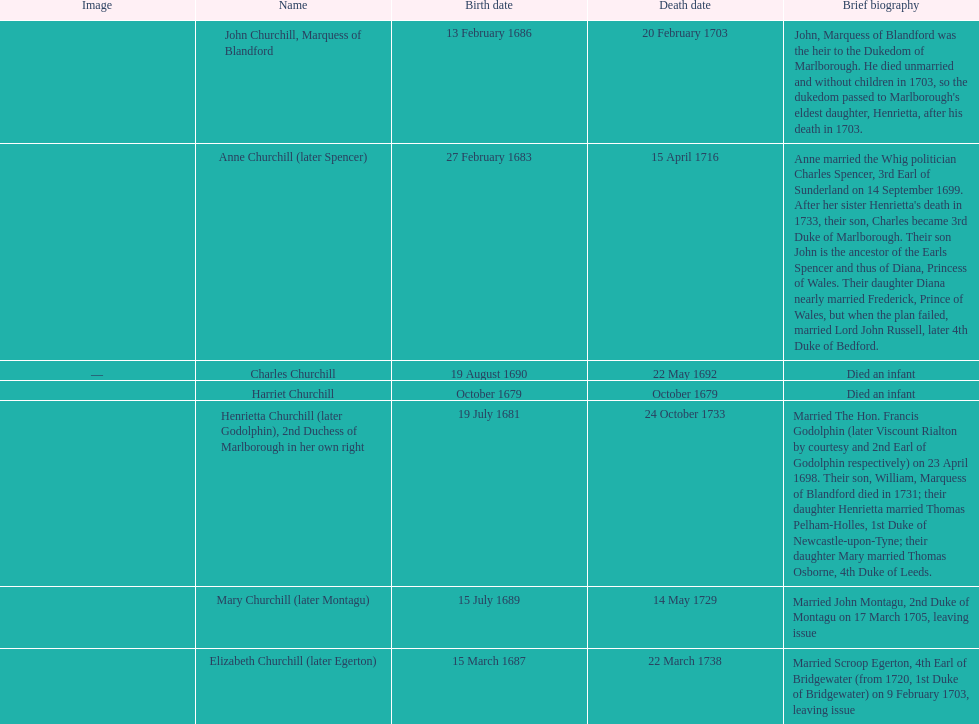Which child was the first to die? Harriet Churchill. 